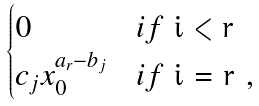<formula> <loc_0><loc_0><loc_500><loc_500>\begin{cases} 0 & i f $ i < r $ \\ c _ { j } x _ { 0 } ^ { a _ { r } - b _ { j } } & i f $ i = r $ , \\ \end{cases}</formula> 